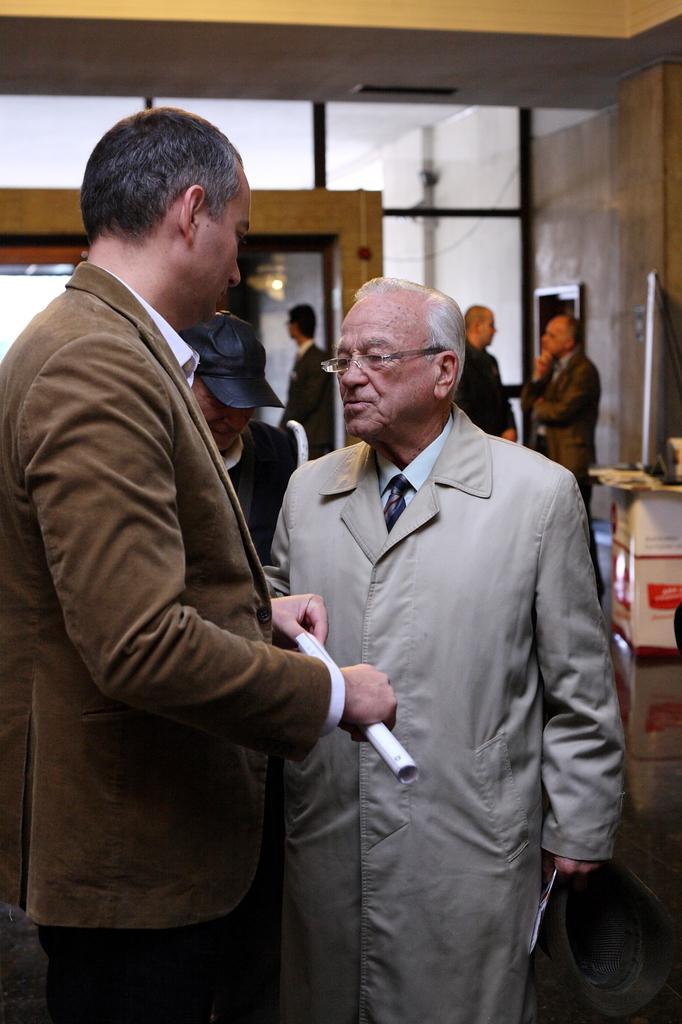How would you summarize this image in a sentence or two? In this picture we can see two men holding a cap, papers with their hands, standing and in the background we can see some people, boxes, wall and some objects. 